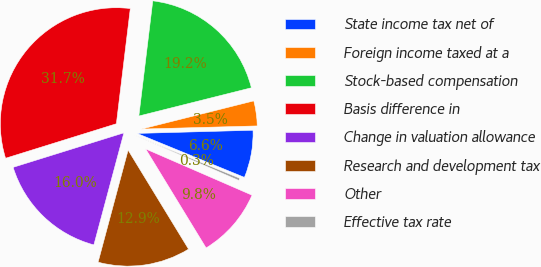<chart> <loc_0><loc_0><loc_500><loc_500><pie_chart><fcel>State income tax net of<fcel>Foreign income taxed at a<fcel>Stock-based compensation<fcel>Basis difference in<fcel>Change in valuation allowance<fcel>Research and development tax<fcel>Other<fcel>Effective tax rate<nl><fcel>6.62%<fcel>3.48%<fcel>19.17%<fcel>31.72%<fcel>16.03%<fcel>12.89%<fcel>9.75%<fcel>0.34%<nl></chart> 